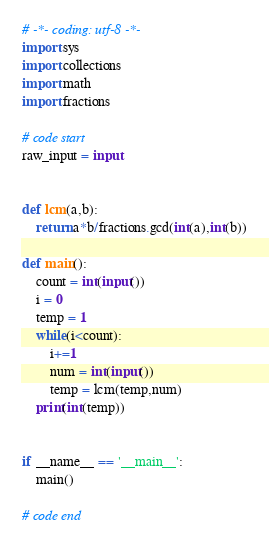Convert code to text. <code><loc_0><loc_0><loc_500><loc_500><_Python_># -*- coding: utf-8 -*-
import sys
import collections
import math
import fractions 

# code start
raw_input = input


def lcm(a,b):
	return a*b/fractions.gcd(int(a),int(b))

def main():
	count = int(input())
	i = 0
	temp = 1
	while(i<count):
		i+=1
		num = int(input())
		temp = lcm(temp,num)
	print(int(temp))


if __name__ == '__main__':
    main()

# code end
</code> 